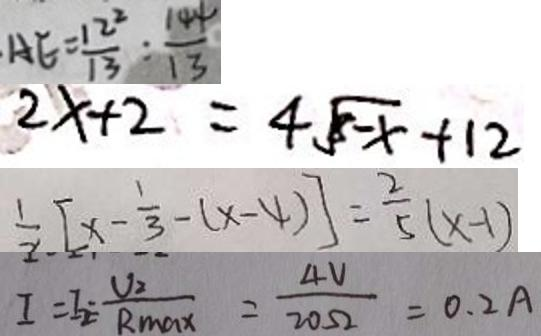<formula> <loc_0><loc_0><loc_500><loc_500>A E = \frac { 1 2 ^ { 2 } } { 1 3 } : \frac { 1 4 4 } { 1 3 } 
 2 x + 2 = 4 \sqrt { 8 - x } + 1 2 
 \frac { 1 } { 2 } [ x - \frac { 1 } { 3 } - ( x - 4 ) ] = \frac { 2 } { 5 } ( x - 1 ) 
 I = I _ { 2 } = \frac { V _ { 2 } } { R _ { \max } } = \frac { 4 V } { 2 0 \Omega } = 0 . 2 A</formula> 